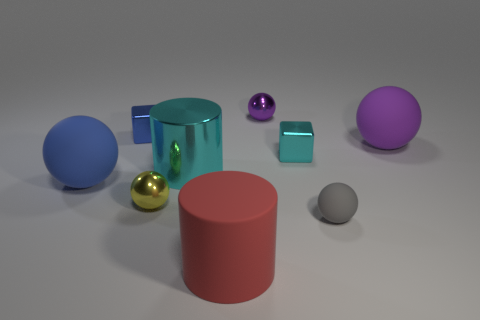How many balls are small purple shiny objects or purple matte objects?
Ensure brevity in your answer.  2. How many blue cubes are behind the small shiny sphere on the right side of the tiny yellow metallic ball?
Give a very brief answer. 0. Does the large red cylinder have the same material as the big blue sphere?
Offer a very short reply. Yes. There is a metal cube that is the same color as the metal cylinder; what is its size?
Provide a short and direct response. Small. Are there any large purple spheres made of the same material as the large cyan cylinder?
Keep it short and to the point. No. There is a small cube behind the purple ball to the right of the ball that is behind the purple rubber sphere; what is its color?
Ensure brevity in your answer.  Blue. How many yellow objects are either cylinders or tiny metal spheres?
Your answer should be very brief. 1. How many other yellow shiny things are the same shape as the tiny yellow thing?
Keep it short and to the point. 0. What is the shape of the blue shiny object that is the same size as the cyan cube?
Offer a terse response. Cube. There is a cyan cylinder; are there any small rubber things behind it?
Offer a very short reply. No. 